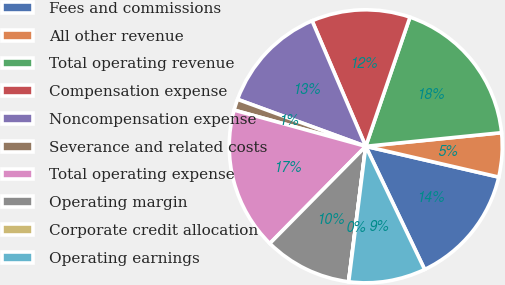Convert chart to OTSL. <chart><loc_0><loc_0><loc_500><loc_500><pie_chart><fcel>Fees and commissions<fcel>All other revenue<fcel>Total operating revenue<fcel>Compensation expense<fcel>Noncompensation expense<fcel>Severance and related costs<fcel>Total operating expense<fcel>Operating margin<fcel>Corporate credit allocation<fcel>Operating earnings<nl><fcel>14.28%<fcel>5.21%<fcel>18.16%<fcel>11.68%<fcel>12.98%<fcel>1.32%<fcel>16.87%<fcel>10.39%<fcel>0.02%<fcel>9.09%<nl></chart> 